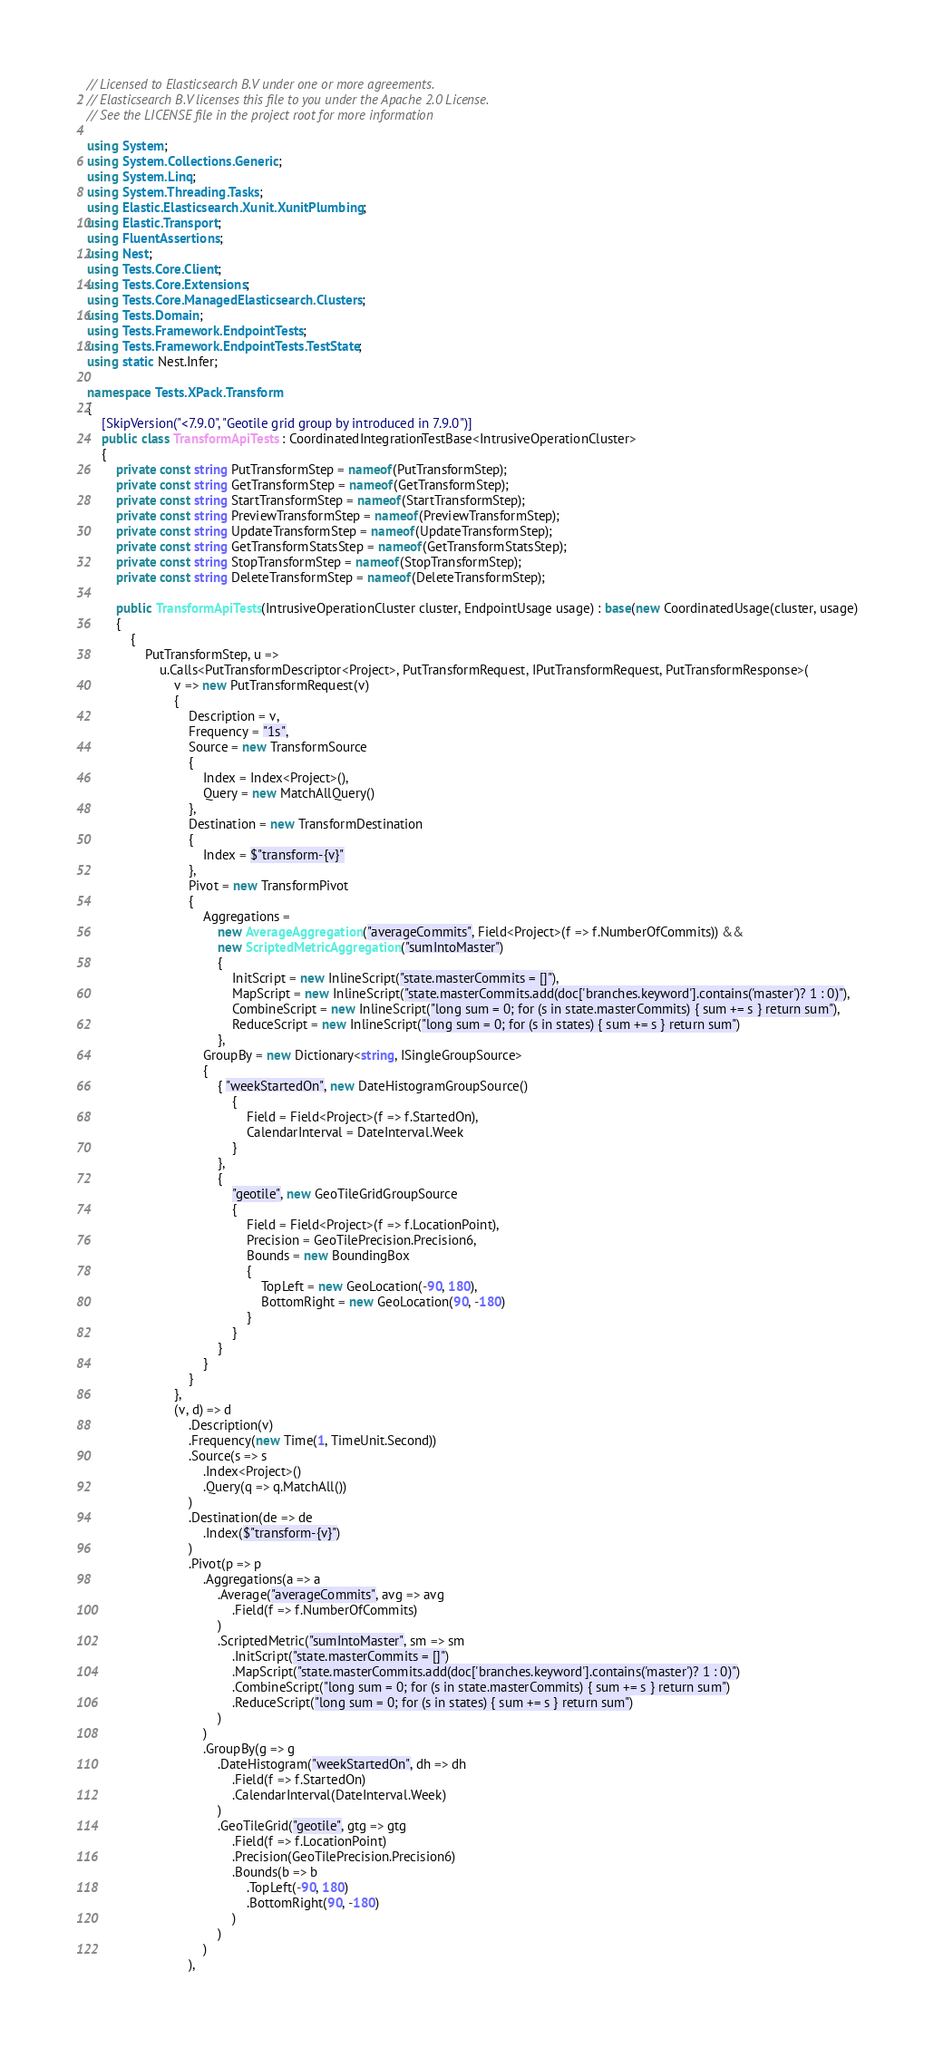Convert code to text. <code><loc_0><loc_0><loc_500><loc_500><_C#_>// Licensed to Elasticsearch B.V under one or more agreements.
// Elasticsearch B.V licenses this file to you under the Apache 2.0 License.
// See the LICENSE file in the project root for more information

using System;
using System.Collections.Generic;
using System.Linq;
using System.Threading.Tasks;
using Elastic.Elasticsearch.Xunit.XunitPlumbing;
using Elastic.Transport;
using FluentAssertions;
using Nest;
using Tests.Core.Client;
using Tests.Core.Extensions;
using Tests.Core.ManagedElasticsearch.Clusters;
using Tests.Domain;
using Tests.Framework.EndpointTests;
using Tests.Framework.EndpointTests.TestState;
using static Nest.Infer;

namespace Tests.XPack.Transform
{
	[SkipVersion("<7.9.0", "Geotile grid group by introduced in 7.9.0")]
	public class TransformApiTests : CoordinatedIntegrationTestBase<IntrusiveOperationCluster>
	{
		private const string PutTransformStep = nameof(PutTransformStep);
		private const string GetTransformStep = nameof(GetTransformStep);
		private const string StartTransformStep = nameof(StartTransformStep);
		private const string PreviewTransformStep = nameof(PreviewTransformStep);
		private const string UpdateTransformStep = nameof(UpdateTransformStep);
		private const string GetTransformStatsStep = nameof(GetTransformStatsStep);
		private const string StopTransformStep = nameof(StopTransformStep);
		private const string DeleteTransformStep = nameof(DeleteTransformStep);

		public TransformApiTests(IntrusiveOperationCluster cluster, EndpointUsage usage) : base(new CoordinatedUsage(cluster, usage)
		{
			{
				PutTransformStep, u =>
					u.Calls<PutTransformDescriptor<Project>, PutTransformRequest, IPutTransformRequest, PutTransformResponse>(
						v => new PutTransformRequest(v)
						{
							Description = v,
							Frequency = "1s",
							Source = new TransformSource
							{
								Index = Index<Project>(),
								Query = new MatchAllQuery()
							},
							Destination = new TransformDestination
							{
								Index = $"transform-{v}"
							},
							Pivot = new TransformPivot
							{
								Aggregations =
									new AverageAggregation("averageCommits", Field<Project>(f => f.NumberOfCommits)) &&
									new ScriptedMetricAggregation("sumIntoMaster")
									{
										InitScript = new InlineScript("state.masterCommits = []"),
										MapScript = new InlineScript("state.masterCommits.add(doc['branches.keyword'].contains('master')? 1 : 0)"),
										CombineScript = new InlineScript("long sum = 0; for (s in state.masterCommits) { sum += s } return sum"),
										ReduceScript = new InlineScript("long sum = 0; for (s in states) { sum += s } return sum")
									},
								GroupBy = new Dictionary<string, ISingleGroupSource>
								{
									{ "weekStartedOn", new DateHistogramGroupSource()
										{
											Field = Field<Project>(f => f.StartedOn),
											CalendarInterval = DateInterval.Week
										}
									},
									{
										"geotile", new GeoTileGridGroupSource
										{
											Field = Field<Project>(f => f.LocationPoint),
											Precision = GeoTilePrecision.Precision6,
											Bounds = new BoundingBox
											{
												TopLeft = new GeoLocation(-90, 180),
												BottomRight = new GeoLocation(90, -180)
											}
										}
									}
								}
							}
						},
						(v, d) => d
							.Description(v)
							.Frequency(new Time(1, TimeUnit.Second))
							.Source(s => s
								.Index<Project>()
								.Query(q => q.MatchAll())
							)
							.Destination(de => de
								.Index($"transform-{v}")
							)
							.Pivot(p => p
								.Aggregations(a => a
									.Average("averageCommits", avg => avg
										.Field(f => f.NumberOfCommits)
									)
									.ScriptedMetric("sumIntoMaster", sm => sm
										.InitScript("state.masterCommits = []")
										.MapScript("state.masterCommits.add(doc['branches.keyword'].contains('master')? 1 : 0)")
										.CombineScript("long sum = 0; for (s in state.masterCommits) { sum += s } return sum")
										.ReduceScript("long sum = 0; for (s in states) { sum += s } return sum")
									)
								)
								.GroupBy(g => g
									.DateHistogram("weekStartedOn", dh => dh
										.Field(f => f.StartedOn)
										.CalendarInterval(DateInterval.Week)
									)
									.GeoTileGrid("geotile", gtg => gtg
										.Field(f => f.LocationPoint)
										.Precision(GeoTilePrecision.Precision6)
										.Bounds(b => b
											.TopLeft(-90, 180)
											.BottomRight(90, -180)
										)
									)
								)
							),</code> 